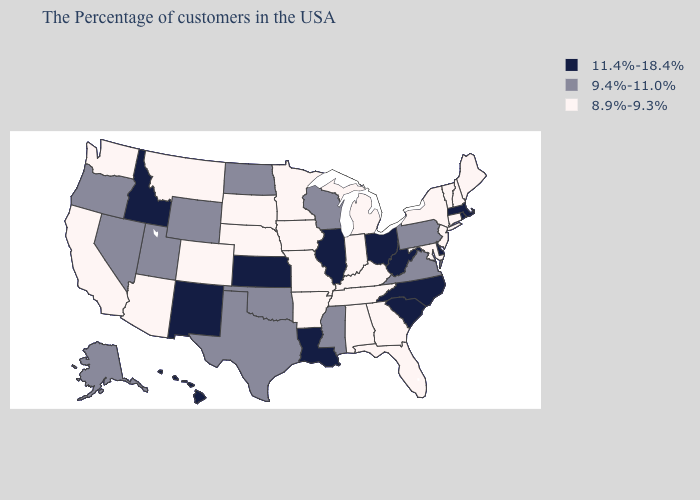Name the states that have a value in the range 9.4%-11.0%?
Be succinct. Pennsylvania, Virginia, Wisconsin, Mississippi, Oklahoma, Texas, North Dakota, Wyoming, Utah, Nevada, Oregon, Alaska. Name the states that have a value in the range 8.9%-9.3%?
Short answer required. Maine, New Hampshire, Vermont, Connecticut, New York, New Jersey, Maryland, Florida, Georgia, Michigan, Kentucky, Indiana, Alabama, Tennessee, Missouri, Arkansas, Minnesota, Iowa, Nebraska, South Dakota, Colorado, Montana, Arizona, California, Washington. Does the first symbol in the legend represent the smallest category?
Be succinct. No. Name the states that have a value in the range 8.9%-9.3%?
Concise answer only. Maine, New Hampshire, Vermont, Connecticut, New York, New Jersey, Maryland, Florida, Georgia, Michigan, Kentucky, Indiana, Alabama, Tennessee, Missouri, Arkansas, Minnesota, Iowa, Nebraska, South Dakota, Colorado, Montana, Arizona, California, Washington. Which states have the lowest value in the USA?
Quick response, please. Maine, New Hampshire, Vermont, Connecticut, New York, New Jersey, Maryland, Florida, Georgia, Michigan, Kentucky, Indiana, Alabama, Tennessee, Missouri, Arkansas, Minnesota, Iowa, Nebraska, South Dakota, Colorado, Montana, Arizona, California, Washington. Name the states that have a value in the range 11.4%-18.4%?
Concise answer only. Massachusetts, Rhode Island, Delaware, North Carolina, South Carolina, West Virginia, Ohio, Illinois, Louisiana, Kansas, New Mexico, Idaho, Hawaii. What is the lowest value in states that border Louisiana?
Answer briefly. 8.9%-9.3%. Name the states that have a value in the range 9.4%-11.0%?
Be succinct. Pennsylvania, Virginia, Wisconsin, Mississippi, Oklahoma, Texas, North Dakota, Wyoming, Utah, Nevada, Oregon, Alaska. Which states have the highest value in the USA?
Give a very brief answer. Massachusetts, Rhode Island, Delaware, North Carolina, South Carolina, West Virginia, Ohio, Illinois, Louisiana, Kansas, New Mexico, Idaho, Hawaii. What is the value of Texas?
Give a very brief answer. 9.4%-11.0%. What is the value of Kentucky?
Quick response, please. 8.9%-9.3%. Name the states that have a value in the range 8.9%-9.3%?
Short answer required. Maine, New Hampshire, Vermont, Connecticut, New York, New Jersey, Maryland, Florida, Georgia, Michigan, Kentucky, Indiana, Alabama, Tennessee, Missouri, Arkansas, Minnesota, Iowa, Nebraska, South Dakota, Colorado, Montana, Arizona, California, Washington. Which states have the highest value in the USA?
Concise answer only. Massachusetts, Rhode Island, Delaware, North Carolina, South Carolina, West Virginia, Ohio, Illinois, Louisiana, Kansas, New Mexico, Idaho, Hawaii. Name the states that have a value in the range 11.4%-18.4%?
Give a very brief answer. Massachusetts, Rhode Island, Delaware, North Carolina, South Carolina, West Virginia, Ohio, Illinois, Louisiana, Kansas, New Mexico, Idaho, Hawaii. Name the states that have a value in the range 11.4%-18.4%?
Keep it brief. Massachusetts, Rhode Island, Delaware, North Carolina, South Carolina, West Virginia, Ohio, Illinois, Louisiana, Kansas, New Mexico, Idaho, Hawaii. 